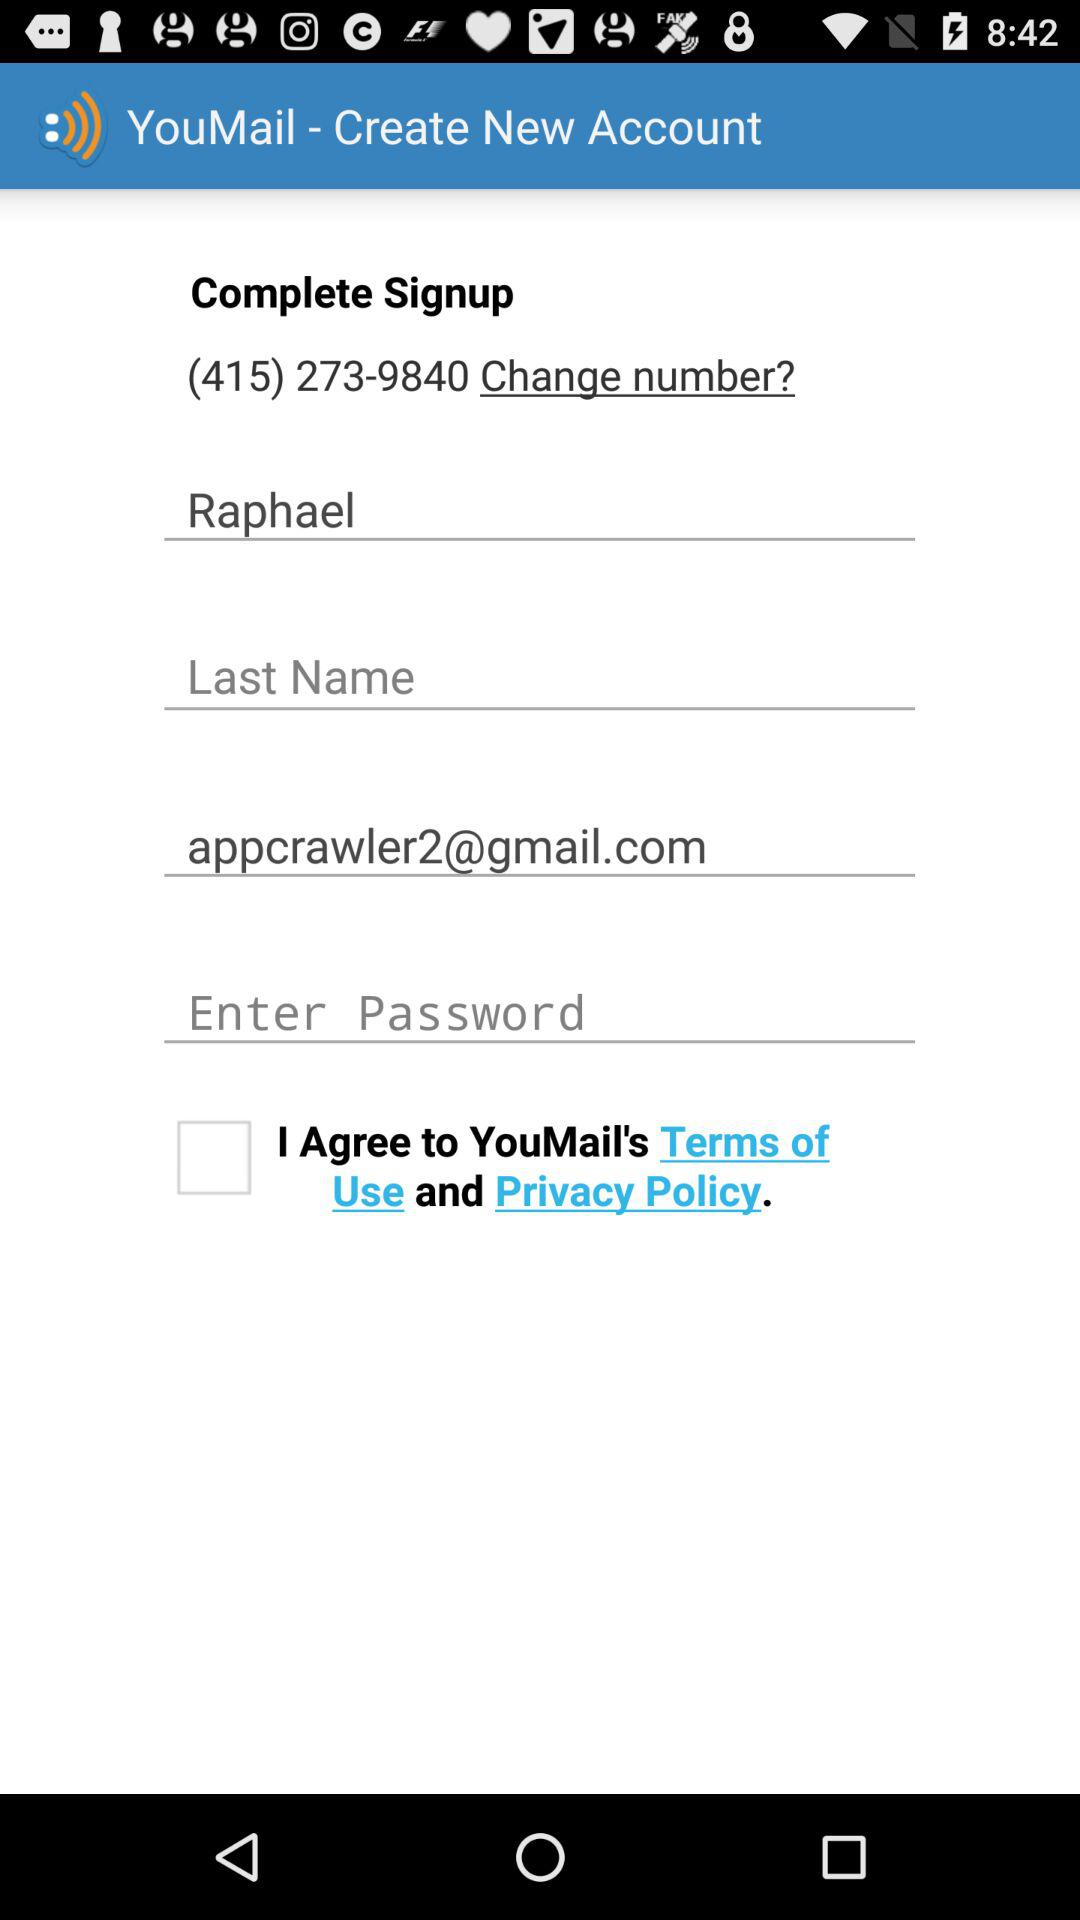What is the email address? The email address is appcrawler2@gmail.com. 